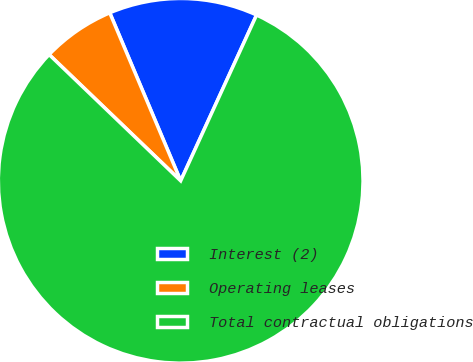<chart> <loc_0><loc_0><loc_500><loc_500><pie_chart><fcel>Interest (2)<fcel>Operating leases<fcel>Total contractual obligations<nl><fcel>13.19%<fcel>6.47%<fcel>80.34%<nl></chart> 